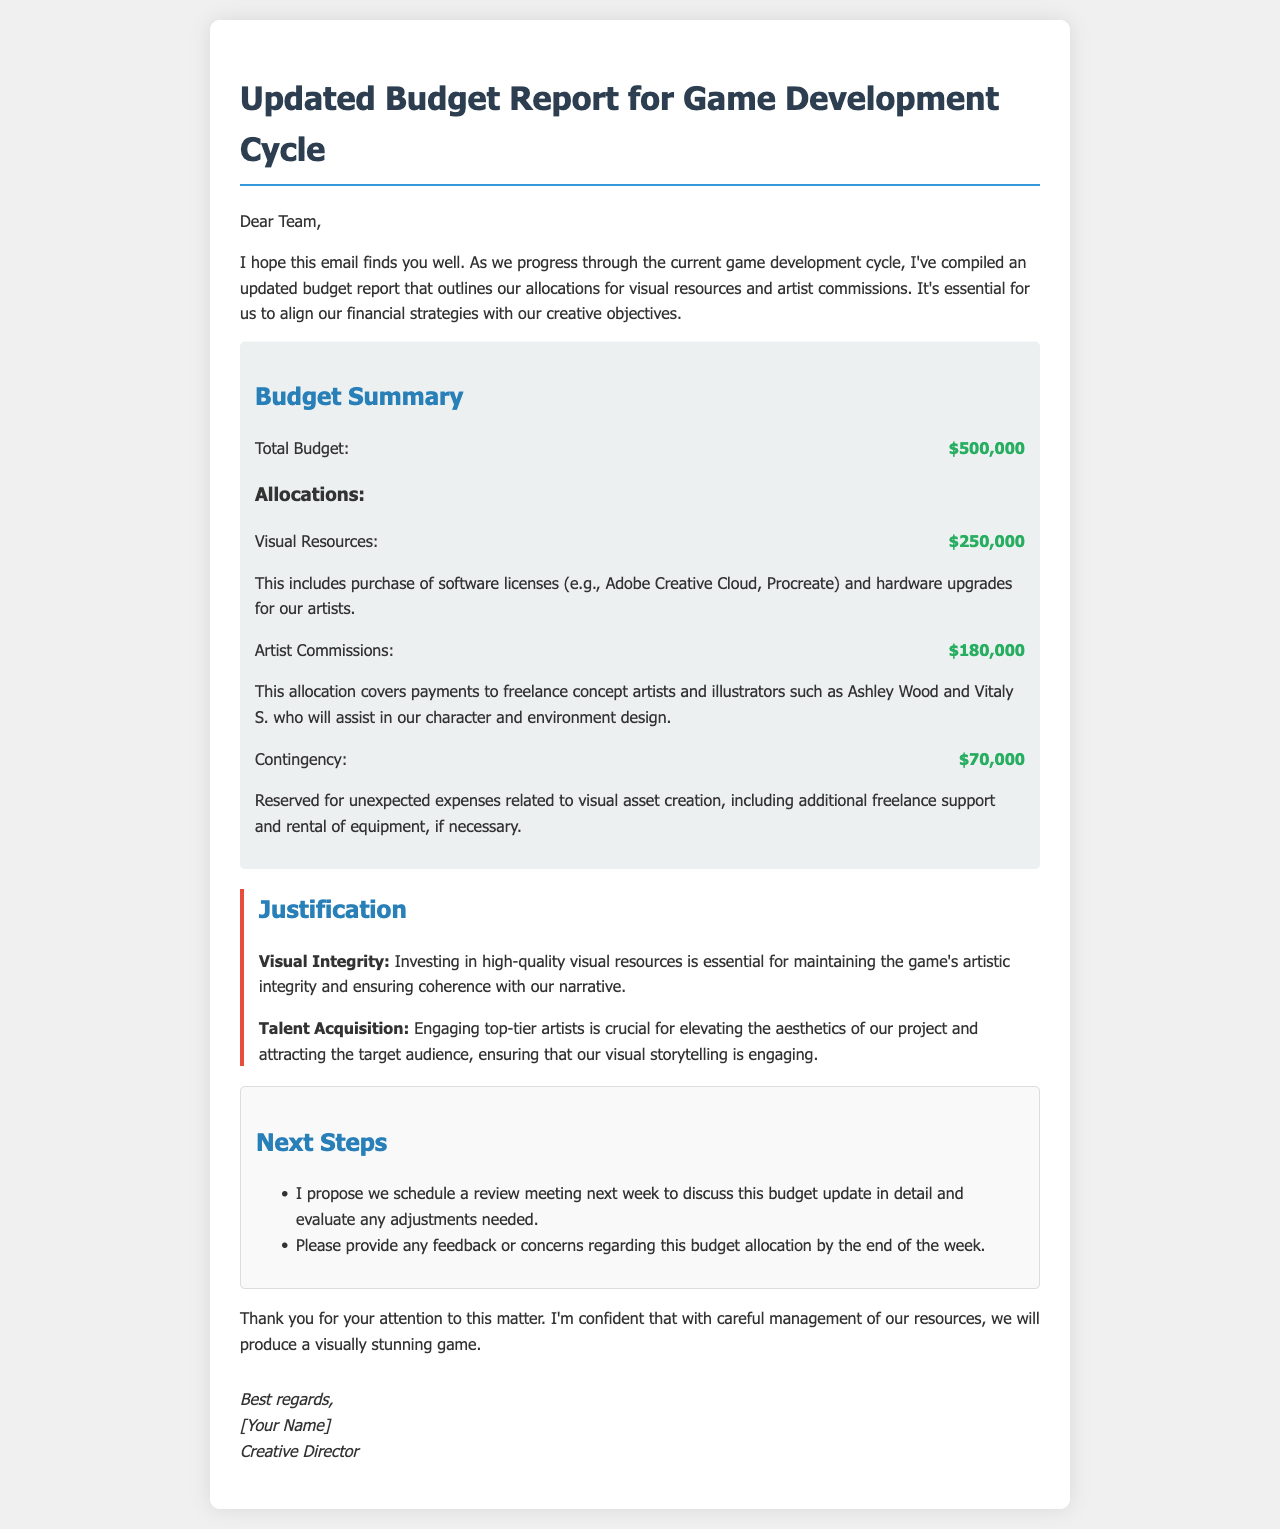What is the total budget? The total budget is clearly stated in the budget summary section of the document.
Answer: $500,000 How much is allocated for visual resources? The allocation for visual resources is specified under the allocations section.
Answer: $250,000 Who are the mentioned freelance artists for commissions? The document lists specific artists who will assist with character and environment design.
Answer: Ashley Wood and Vitaly S What is the contingency amount? The contingency amount is noted in the budget allocations for unexpected expenses.
Answer: $70,000 Why is investing in high-quality visual resources emphasized? This is explained as essential for maintaining the game's artistic integrity and coherence with the narrative.
Answer: Visual Integrity What percentage of the total budget is allocated to artist commissions? This requires calculating the commission allocation against the total budget provided.
Answer: 36% What is proposed for the next step regarding the budget update? The document suggests scheduling a review meeting to discuss the budget update in detail.
Answer: Schedule a review meeting Until when should feedback on the budget allocation be provided? The document states a deadline for feedback regarding the budget allocation.
Answer: By the end of the week 